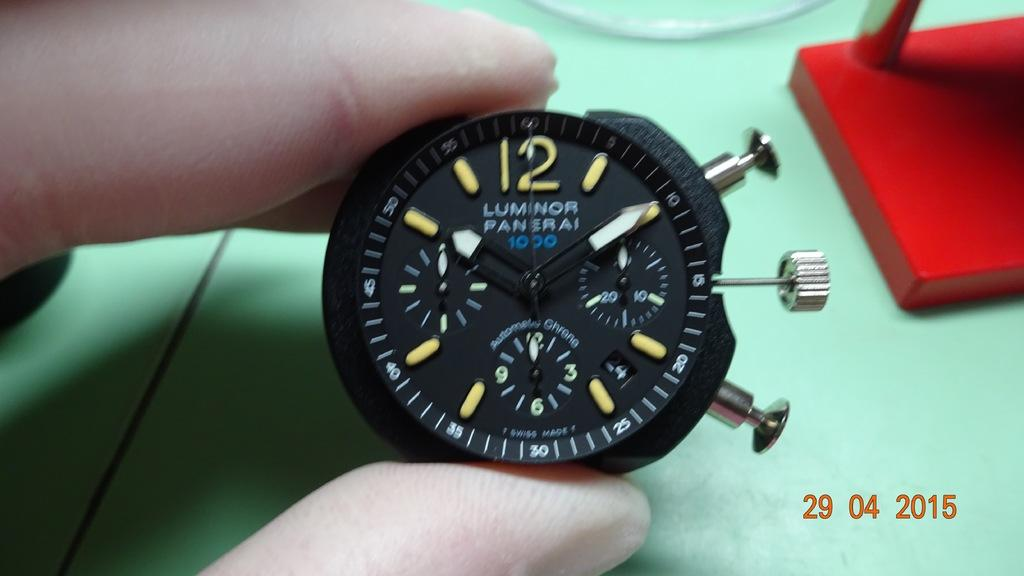<image>
Write a terse but informative summary of the picture. A gauge has the words Luminor and Panerai written on it. 